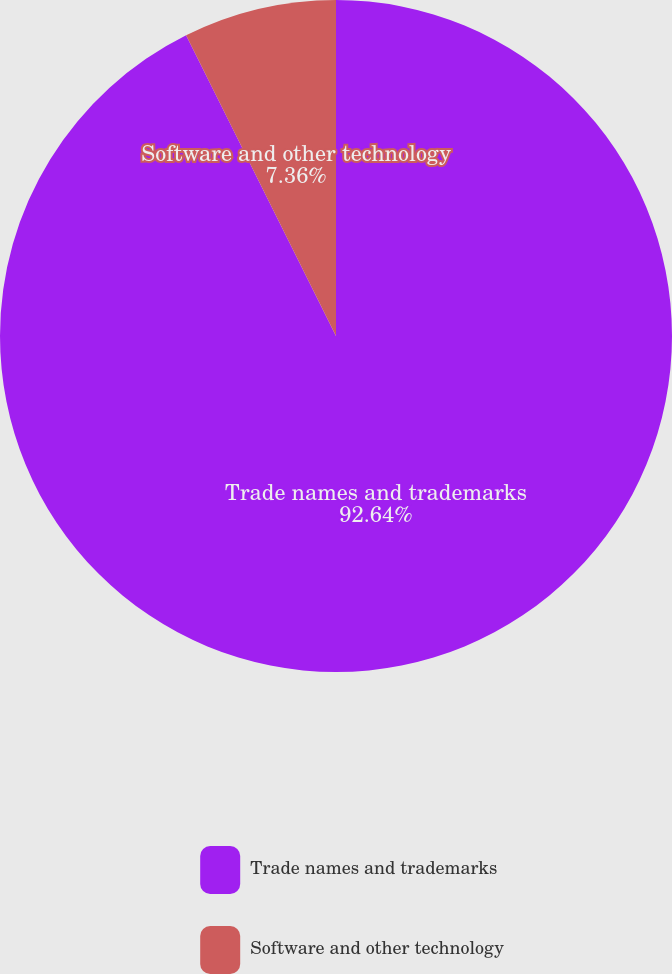Convert chart. <chart><loc_0><loc_0><loc_500><loc_500><pie_chart><fcel>Trade names and trademarks<fcel>Software and other technology<nl><fcel>92.64%<fcel>7.36%<nl></chart> 